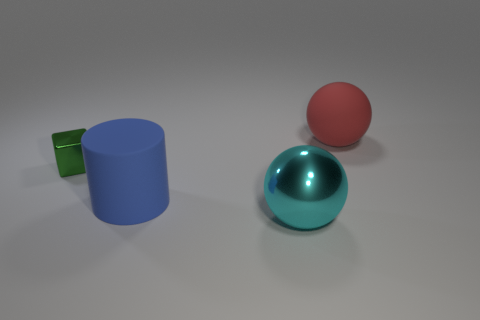Add 1 blue metallic things. How many objects exist? 5 Add 3 large gray cubes. How many large gray cubes exist? 3 Subtract 0 red cylinders. How many objects are left? 4 Subtract all cubes. How many objects are left? 3 Subtract all big things. Subtract all large red rubber spheres. How many objects are left? 0 Add 4 metal spheres. How many metal spheres are left? 5 